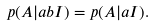<formula> <loc_0><loc_0><loc_500><loc_500>p ( A | a b I ) = p ( A | a I ) .</formula> 